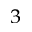<formula> <loc_0><loc_0><loc_500><loc_500>^ { 3 }</formula> 